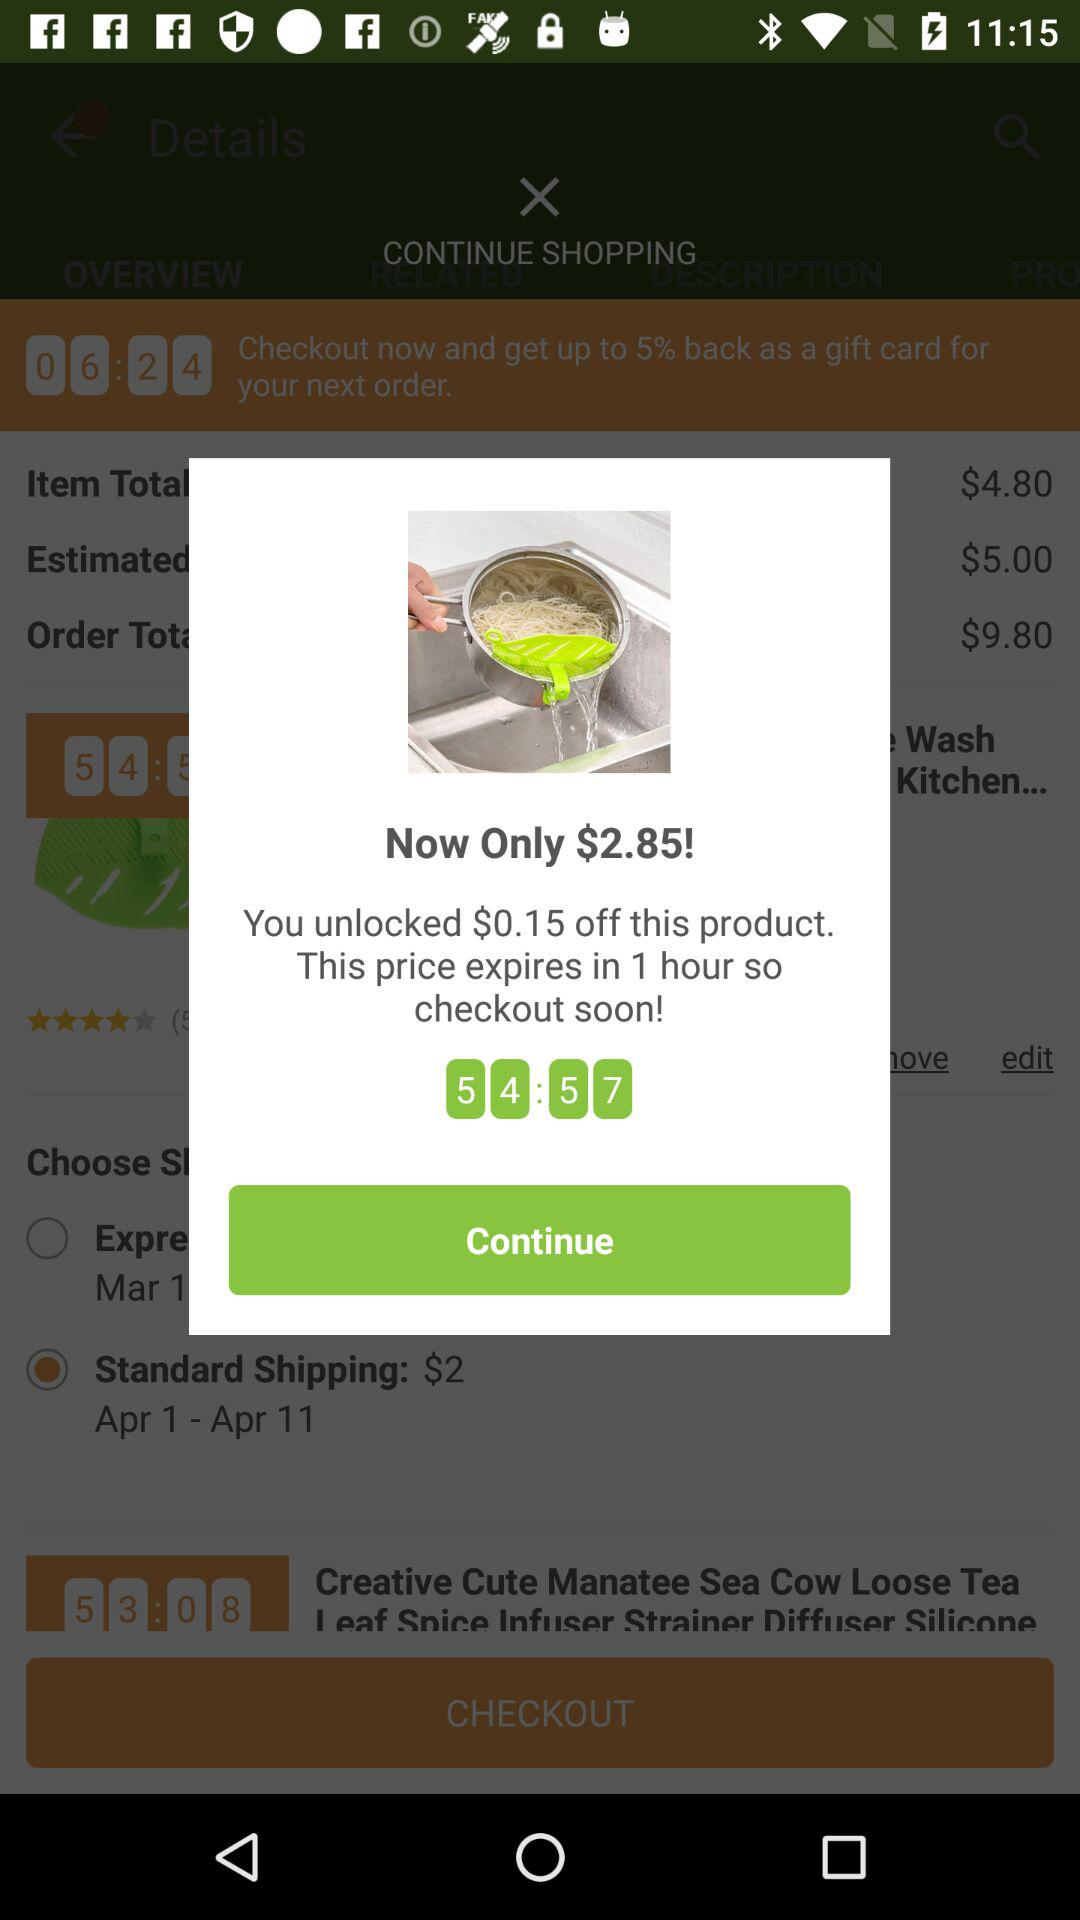What's the standard shipping cost? The standard shipping cost is $2. 